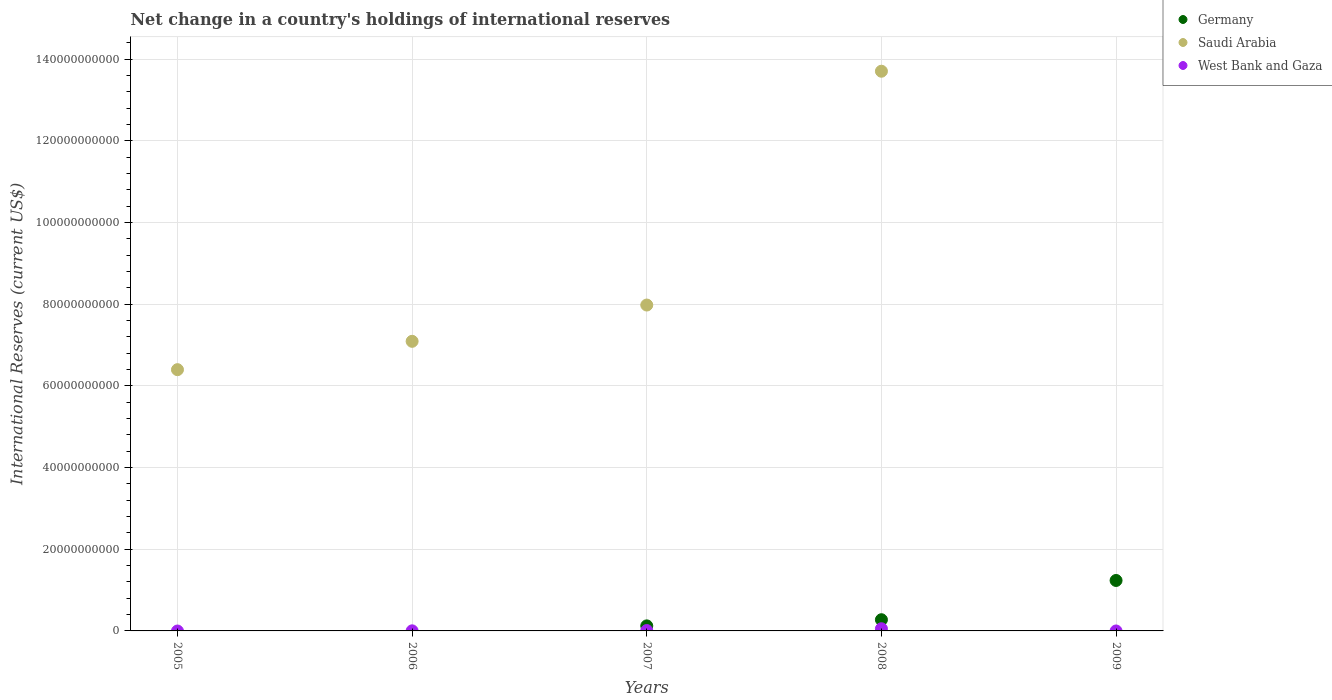Is the number of dotlines equal to the number of legend labels?
Keep it short and to the point. No. What is the international reserves in Saudi Arabia in 2006?
Your response must be concise. 7.09e+1. Across all years, what is the maximum international reserves in Germany?
Offer a terse response. 1.24e+1. Across all years, what is the minimum international reserves in Saudi Arabia?
Keep it short and to the point. 0. In which year was the international reserves in West Bank and Gaza maximum?
Offer a terse response. 2008. What is the total international reserves in Germany in the graph?
Make the answer very short. 1.63e+1. What is the difference between the international reserves in Saudi Arabia in 2006 and that in 2007?
Your response must be concise. -8.88e+09. What is the difference between the international reserves in Germany in 2006 and the international reserves in Saudi Arabia in 2009?
Provide a succinct answer. 0. What is the average international reserves in Germany per year?
Your answer should be compact. 3.27e+09. In the year 2006, what is the difference between the international reserves in West Bank and Gaza and international reserves in Saudi Arabia?
Provide a short and direct response. -7.09e+1. In how many years, is the international reserves in Saudi Arabia greater than 16000000000 US$?
Ensure brevity in your answer.  4. What is the ratio of the international reserves in West Bank and Gaza in 2007 to that in 2008?
Offer a terse response. 0.17. Is the difference between the international reserves in West Bank and Gaza in 2007 and 2008 greater than the difference between the international reserves in Saudi Arabia in 2007 and 2008?
Provide a succinct answer. Yes. What is the difference between the highest and the second highest international reserves in Saudi Arabia?
Offer a very short reply. 5.72e+1. What is the difference between the highest and the lowest international reserves in Germany?
Give a very brief answer. 1.24e+1. In how many years, is the international reserves in West Bank and Gaza greater than the average international reserves in West Bank and Gaza taken over all years?
Provide a succinct answer. 1. Does the international reserves in Germany monotonically increase over the years?
Your response must be concise. No. Is the international reserves in Saudi Arabia strictly greater than the international reserves in Germany over the years?
Ensure brevity in your answer.  No. How many dotlines are there?
Provide a succinct answer. 3. How many years are there in the graph?
Make the answer very short. 5. What is the difference between two consecutive major ticks on the Y-axis?
Provide a succinct answer. 2.00e+1. Are the values on the major ticks of Y-axis written in scientific E-notation?
Offer a very short reply. No. Does the graph contain any zero values?
Make the answer very short. Yes. Does the graph contain grids?
Your answer should be very brief. Yes. How many legend labels are there?
Your response must be concise. 3. What is the title of the graph?
Provide a short and direct response. Net change in a country's holdings of international reserves. What is the label or title of the X-axis?
Ensure brevity in your answer.  Years. What is the label or title of the Y-axis?
Your answer should be compact. International Reserves (current US$). What is the International Reserves (current US$) of Saudi Arabia in 2005?
Ensure brevity in your answer.  6.40e+1. What is the International Reserves (current US$) in West Bank and Gaza in 2005?
Offer a very short reply. 0. What is the International Reserves (current US$) of Saudi Arabia in 2006?
Offer a terse response. 7.09e+1. What is the International Reserves (current US$) of West Bank and Gaza in 2006?
Offer a very short reply. 2.23e+07. What is the International Reserves (current US$) in Germany in 2007?
Your answer should be very brief. 1.23e+09. What is the International Reserves (current US$) in Saudi Arabia in 2007?
Ensure brevity in your answer.  7.98e+1. What is the International Reserves (current US$) of West Bank and Gaza in 2007?
Your response must be concise. 9.13e+07. What is the International Reserves (current US$) in Germany in 2008?
Ensure brevity in your answer.  2.74e+09. What is the International Reserves (current US$) in Saudi Arabia in 2008?
Make the answer very short. 1.37e+11. What is the International Reserves (current US$) of West Bank and Gaza in 2008?
Ensure brevity in your answer.  5.34e+08. What is the International Reserves (current US$) of Germany in 2009?
Provide a short and direct response. 1.24e+1. What is the International Reserves (current US$) in Saudi Arabia in 2009?
Your answer should be compact. 0. What is the International Reserves (current US$) in West Bank and Gaza in 2009?
Your answer should be very brief. 0. Across all years, what is the maximum International Reserves (current US$) in Germany?
Ensure brevity in your answer.  1.24e+1. Across all years, what is the maximum International Reserves (current US$) in Saudi Arabia?
Ensure brevity in your answer.  1.37e+11. Across all years, what is the maximum International Reserves (current US$) in West Bank and Gaza?
Provide a short and direct response. 5.34e+08. Across all years, what is the minimum International Reserves (current US$) of Germany?
Offer a very short reply. 0. Across all years, what is the minimum International Reserves (current US$) in West Bank and Gaza?
Keep it short and to the point. 0. What is the total International Reserves (current US$) in Germany in the graph?
Keep it short and to the point. 1.63e+1. What is the total International Reserves (current US$) of Saudi Arabia in the graph?
Ensure brevity in your answer.  3.52e+11. What is the total International Reserves (current US$) in West Bank and Gaza in the graph?
Offer a terse response. 6.47e+08. What is the difference between the International Reserves (current US$) of Saudi Arabia in 2005 and that in 2006?
Make the answer very short. -6.94e+09. What is the difference between the International Reserves (current US$) in Saudi Arabia in 2005 and that in 2007?
Make the answer very short. -1.58e+1. What is the difference between the International Reserves (current US$) of Saudi Arabia in 2005 and that in 2008?
Keep it short and to the point. -7.31e+1. What is the difference between the International Reserves (current US$) of Saudi Arabia in 2006 and that in 2007?
Ensure brevity in your answer.  -8.88e+09. What is the difference between the International Reserves (current US$) of West Bank and Gaza in 2006 and that in 2007?
Offer a terse response. -6.90e+07. What is the difference between the International Reserves (current US$) of Saudi Arabia in 2006 and that in 2008?
Provide a short and direct response. -6.61e+1. What is the difference between the International Reserves (current US$) of West Bank and Gaza in 2006 and that in 2008?
Give a very brief answer. -5.11e+08. What is the difference between the International Reserves (current US$) in Germany in 2007 and that in 2008?
Offer a very short reply. -1.51e+09. What is the difference between the International Reserves (current US$) in Saudi Arabia in 2007 and that in 2008?
Keep it short and to the point. -5.72e+1. What is the difference between the International Reserves (current US$) in West Bank and Gaza in 2007 and that in 2008?
Your answer should be very brief. -4.43e+08. What is the difference between the International Reserves (current US$) of Germany in 2007 and that in 2009?
Keep it short and to the point. -1.11e+1. What is the difference between the International Reserves (current US$) in Germany in 2008 and that in 2009?
Give a very brief answer. -9.61e+09. What is the difference between the International Reserves (current US$) of Saudi Arabia in 2005 and the International Reserves (current US$) of West Bank and Gaza in 2006?
Keep it short and to the point. 6.39e+1. What is the difference between the International Reserves (current US$) in Saudi Arabia in 2005 and the International Reserves (current US$) in West Bank and Gaza in 2007?
Offer a very short reply. 6.39e+1. What is the difference between the International Reserves (current US$) in Saudi Arabia in 2005 and the International Reserves (current US$) in West Bank and Gaza in 2008?
Provide a succinct answer. 6.34e+1. What is the difference between the International Reserves (current US$) in Saudi Arabia in 2006 and the International Reserves (current US$) in West Bank and Gaza in 2007?
Your answer should be very brief. 7.08e+1. What is the difference between the International Reserves (current US$) of Saudi Arabia in 2006 and the International Reserves (current US$) of West Bank and Gaza in 2008?
Your answer should be very brief. 7.04e+1. What is the difference between the International Reserves (current US$) of Germany in 2007 and the International Reserves (current US$) of Saudi Arabia in 2008?
Offer a terse response. -1.36e+11. What is the difference between the International Reserves (current US$) in Germany in 2007 and the International Reserves (current US$) in West Bank and Gaza in 2008?
Provide a short and direct response. 7.00e+08. What is the difference between the International Reserves (current US$) of Saudi Arabia in 2007 and the International Reserves (current US$) of West Bank and Gaza in 2008?
Keep it short and to the point. 7.93e+1. What is the average International Reserves (current US$) in Germany per year?
Ensure brevity in your answer.  3.27e+09. What is the average International Reserves (current US$) of Saudi Arabia per year?
Provide a succinct answer. 7.03e+1. What is the average International Reserves (current US$) of West Bank and Gaza per year?
Ensure brevity in your answer.  1.29e+08. In the year 2006, what is the difference between the International Reserves (current US$) in Saudi Arabia and International Reserves (current US$) in West Bank and Gaza?
Offer a very short reply. 7.09e+1. In the year 2007, what is the difference between the International Reserves (current US$) of Germany and International Reserves (current US$) of Saudi Arabia?
Make the answer very short. -7.86e+1. In the year 2007, what is the difference between the International Reserves (current US$) of Germany and International Reserves (current US$) of West Bank and Gaza?
Keep it short and to the point. 1.14e+09. In the year 2007, what is the difference between the International Reserves (current US$) in Saudi Arabia and International Reserves (current US$) in West Bank and Gaza?
Offer a very short reply. 7.97e+1. In the year 2008, what is the difference between the International Reserves (current US$) of Germany and International Reserves (current US$) of Saudi Arabia?
Offer a very short reply. -1.34e+11. In the year 2008, what is the difference between the International Reserves (current US$) in Germany and International Reserves (current US$) in West Bank and Gaza?
Provide a succinct answer. 2.21e+09. In the year 2008, what is the difference between the International Reserves (current US$) of Saudi Arabia and International Reserves (current US$) of West Bank and Gaza?
Keep it short and to the point. 1.37e+11. What is the ratio of the International Reserves (current US$) of Saudi Arabia in 2005 to that in 2006?
Give a very brief answer. 0.9. What is the ratio of the International Reserves (current US$) in Saudi Arabia in 2005 to that in 2007?
Your answer should be compact. 0.8. What is the ratio of the International Reserves (current US$) of Saudi Arabia in 2005 to that in 2008?
Your answer should be very brief. 0.47. What is the ratio of the International Reserves (current US$) in Saudi Arabia in 2006 to that in 2007?
Offer a terse response. 0.89. What is the ratio of the International Reserves (current US$) of West Bank and Gaza in 2006 to that in 2007?
Give a very brief answer. 0.24. What is the ratio of the International Reserves (current US$) of Saudi Arabia in 2006 to that in 2008?
Offer a terse response. 0.52. What is the ratio of the International Reserves (current US$) of West Bank and Gaza in 2006 to that in 2008?
Give a very brief answer. 0.04. What is the ratio of the International Reserves (current US$) of Germany in 2007 to that in 2008?
Provide a short and direct response. 0.45. What is the ratio of the International Reserves (current US$) of Saudi Arabia in 2007 to that in 2008?
Your response must be concise. 0.58. What is the ratio of the International Reserves (current US$) of West Bank and Gaza in 2007 to that in 2008?
Your answer should be very brief. 0.17. What is the ratio of the International Reserves (current US$) of Germany in 2007 to that in 2009?
Offer a terse response. 0.1. What is the ratio of the International Reserves (current US$) of Germany in 2008 to that in 2009?
Your response must be concise. 0.22. What is the difference between the highest and the second highest International Reserves (current US$) of Germany?
Keep it short and to the point. 9.61e+09. What is the difference between the highest and the second highest International Reserves (current US$) in Saudi Arabia?
Your response must be concise. 5.72e+1. What is the difference between the highest and the second highest International Reserves (current US$) of West Bank and Gaza?
Provide a succinct answer. 4.43e+08. What is the difference between the highest and the lowest International Reserves (current US$) of Germany?
Make the answer very short. 1.24e+1. What is the difference between the highest and the lowest International Reserves (current US$) in Saudi Arabia?
Your answer should be compact. 1.37e+11. What is the difference between the highest and the lowest International Reserves (current US$) in West Bank and Gaza?
Give a very brief answer. 5.34e+08. 